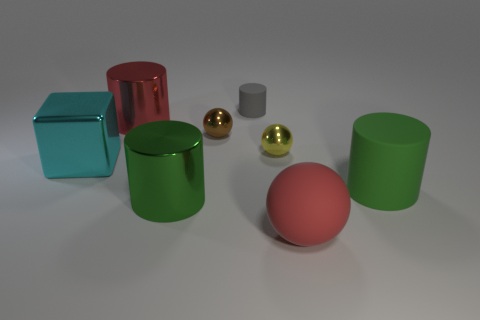There is a red thing that is behind the tiny brown object; is it the same size as the green cylinder right of the tiny brown metallic thing?
Give a very brief answer. Yes. There is a rubber thing that is in front of the cyan thing and behind the red rubber sphere; how big is it?
Your answer should be compact. Large. What color is the other metal object that is the same shape as the brown shiny thing?
Make the answer very short. Yellow. Are there more large metallic objects in front of the green matte cylinder than large red matte objects that are left of the red metal cylinder?
Ensure brevity in your answer.  Yes. How many other objects are the same shape as the small rubber thing?
Offer a very short reply. 3. Is there a big sphere behind the large green cylinder that is on the left side of the gray cylinder?
Offer a terse response. No. What number of big green cylinders are there?
Provide a short and direct response. 2. Do the big matte ball and the metallic object that is on the right side of the gray matte cylinder have the same color?
Make the answer very short. No. Are there more red shiny cylinders than green cylinders?
Ensure brevity in your answer.  No. Is there any other thing of the same color as the small cylinder?
Provide a succinct answer. No. 